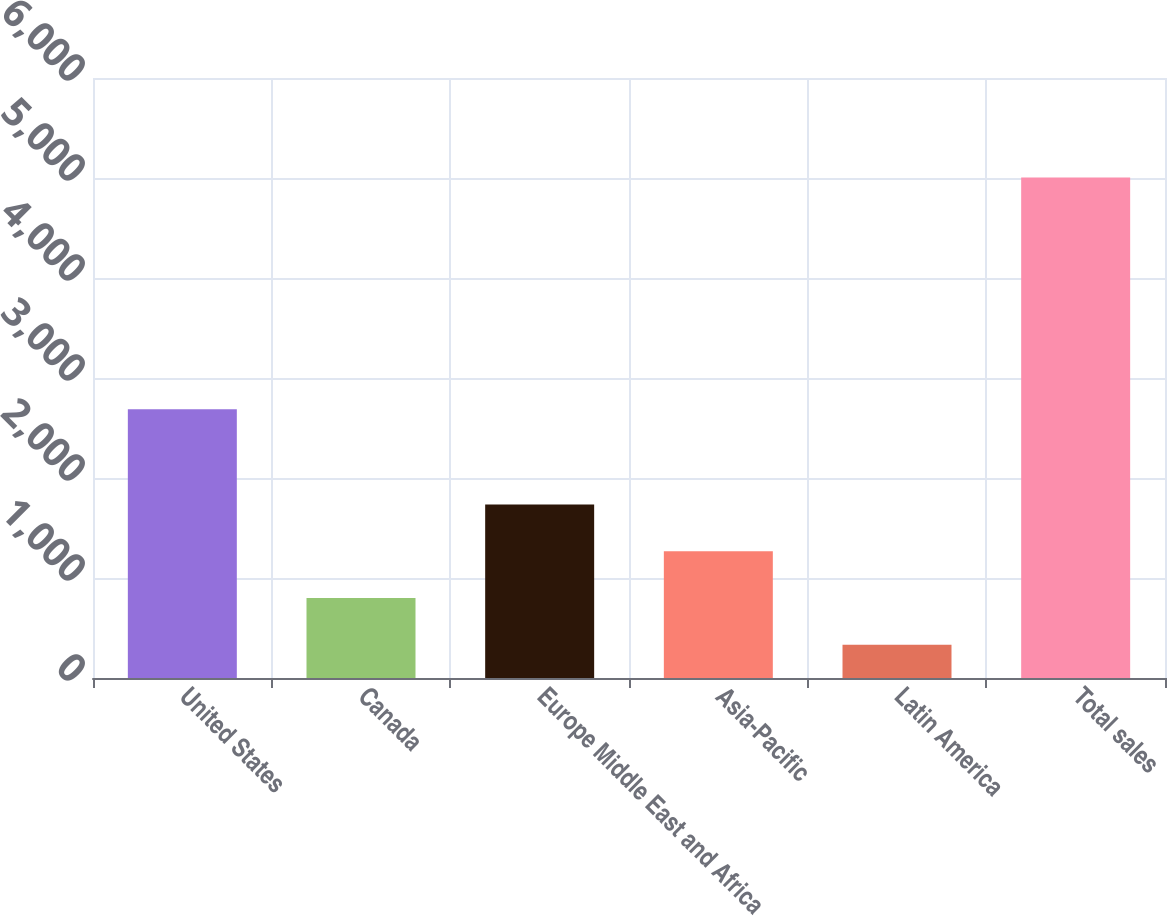<chart> <loc_0><loc_0><loc_500><loc_500><bar_chart><fcel>United States<fcel>Canada<fcel>Europe Middle East and Africa<fcel>Asia-Pacific<fcel>Latin America<fcel>Total sales<nl><fcel>2687<fcel>799.91<fcel>1734.13<fcel>1267.02<fcel>332.8<fcel>5003.9<nl></chart> 